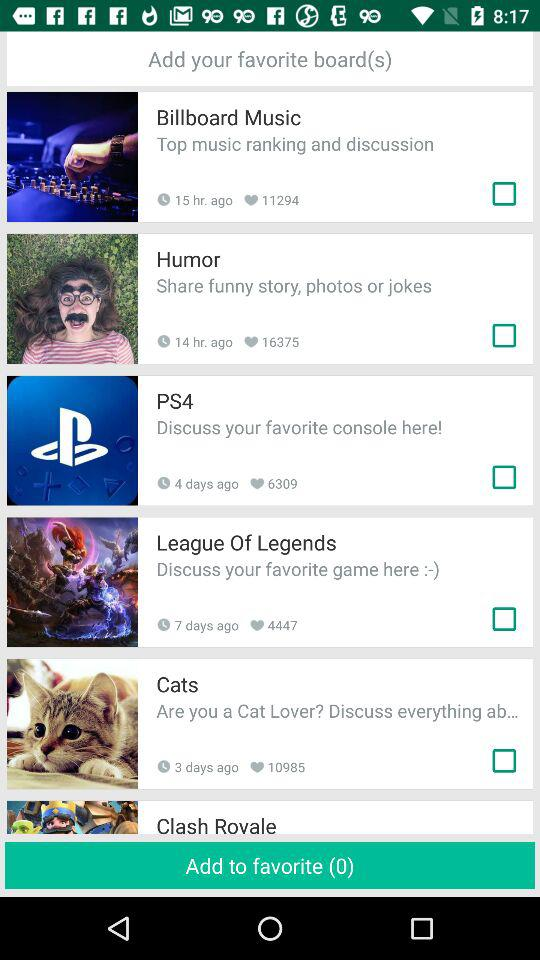What is the status of "Billboard Music"? The status of "Billboard Music" is "off". 